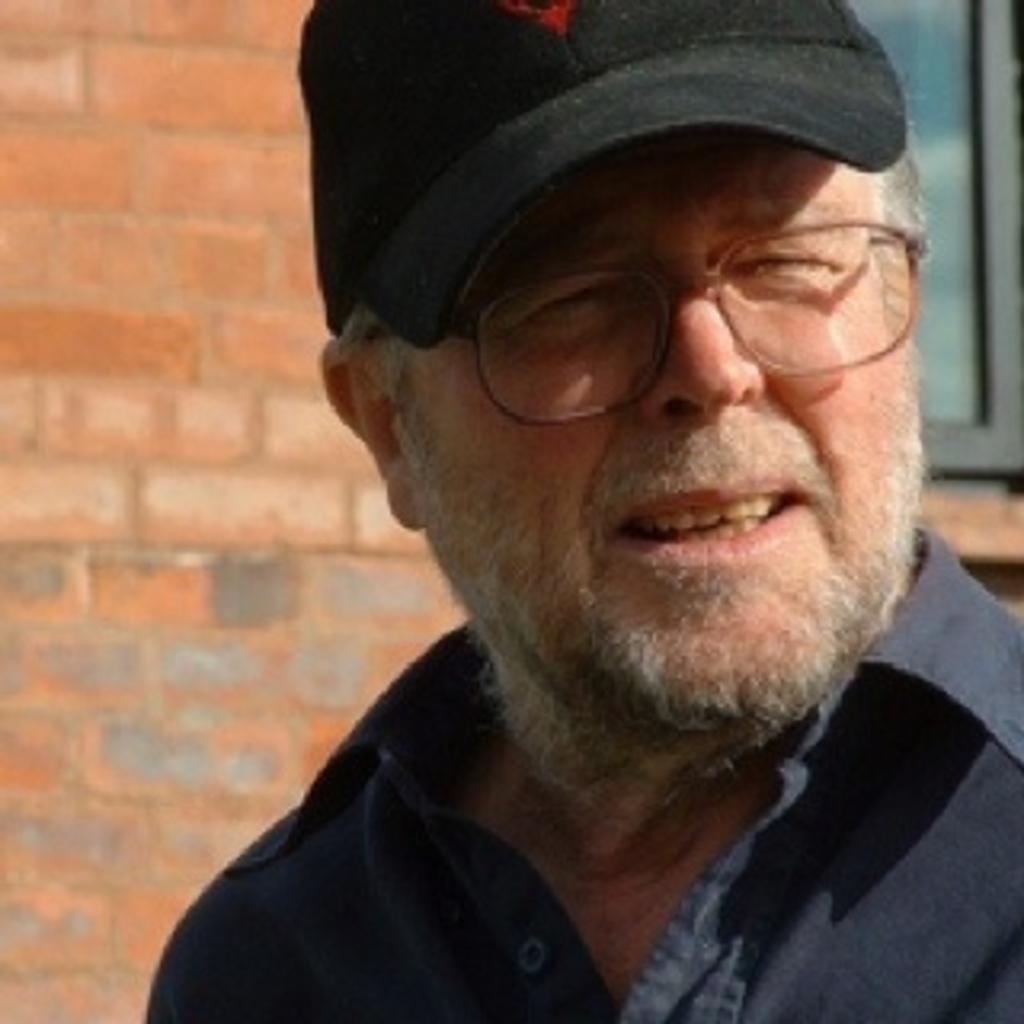Could you give a brief overview of what you see in this image? In this image in the foreground there is one person who is wearing a hat and spectacles, and in the background there is a wall and window. 